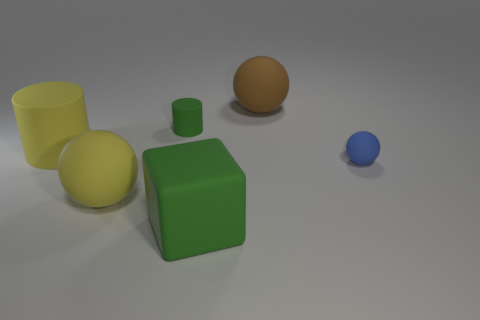What number of things are in front of the yellow ball?
Your response must be concise. 1. Is the shape of the tiny blue thing that is on the right side of the large brown rubber thing the same as  the big green matte object?
Make the answer very short. No. Is there a large yellow thing that has the same shape as the big green thing?
Provide a succinct answer. No. There is a cylinder that is the same color as the cube; what is it made of?
Keep it short and to the point. Rubber. What is the shape of the object behind the matte cylinder that is to the right of the large cylinder?
Your answer should be compact. Sphere. How many tiny blue objects have the same material as the block?
Your response must be concise. 1. The big cylinder that is made of the same material as the tiny ball is what color?
Your response must be concise. Yellow. What size is the green rubber thing that is behind the green object that is in front of the big yellow object that is behind the small blue rubber sphere?
Your answer should be very brief. Small. Is the number of large matte blocks less than the number of big yellow rubber things?
Offer a terse response. Yes. The other object that is the same shape as the tiny green object is what color?
Offer a terse response. Yellow. 